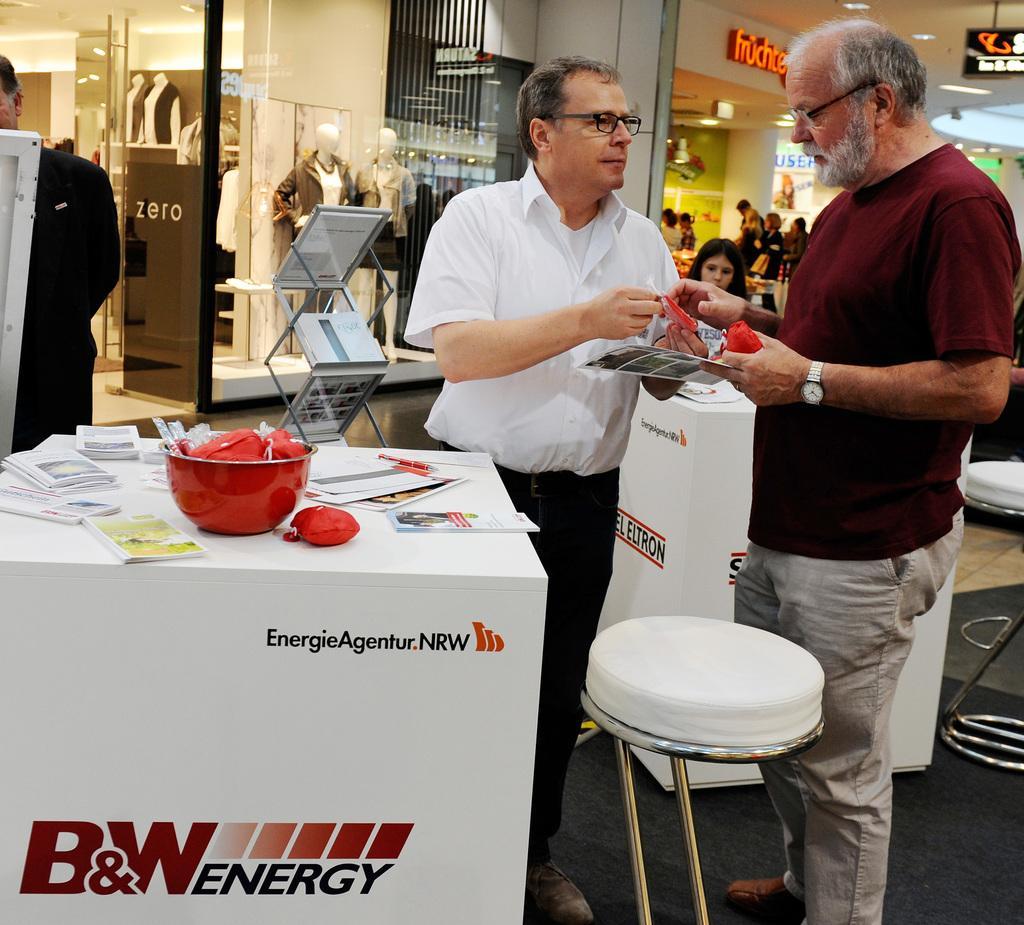Please provide a concise description of this image. In the image there are two persons holding a card behind the table. On table we can see a bowl,books,paper,pen on right side behind the red color shirt man we can see a chair. On left side behind white color shirt man we can see a clothes shop in background we can see a woman and a group of people who are standing. 